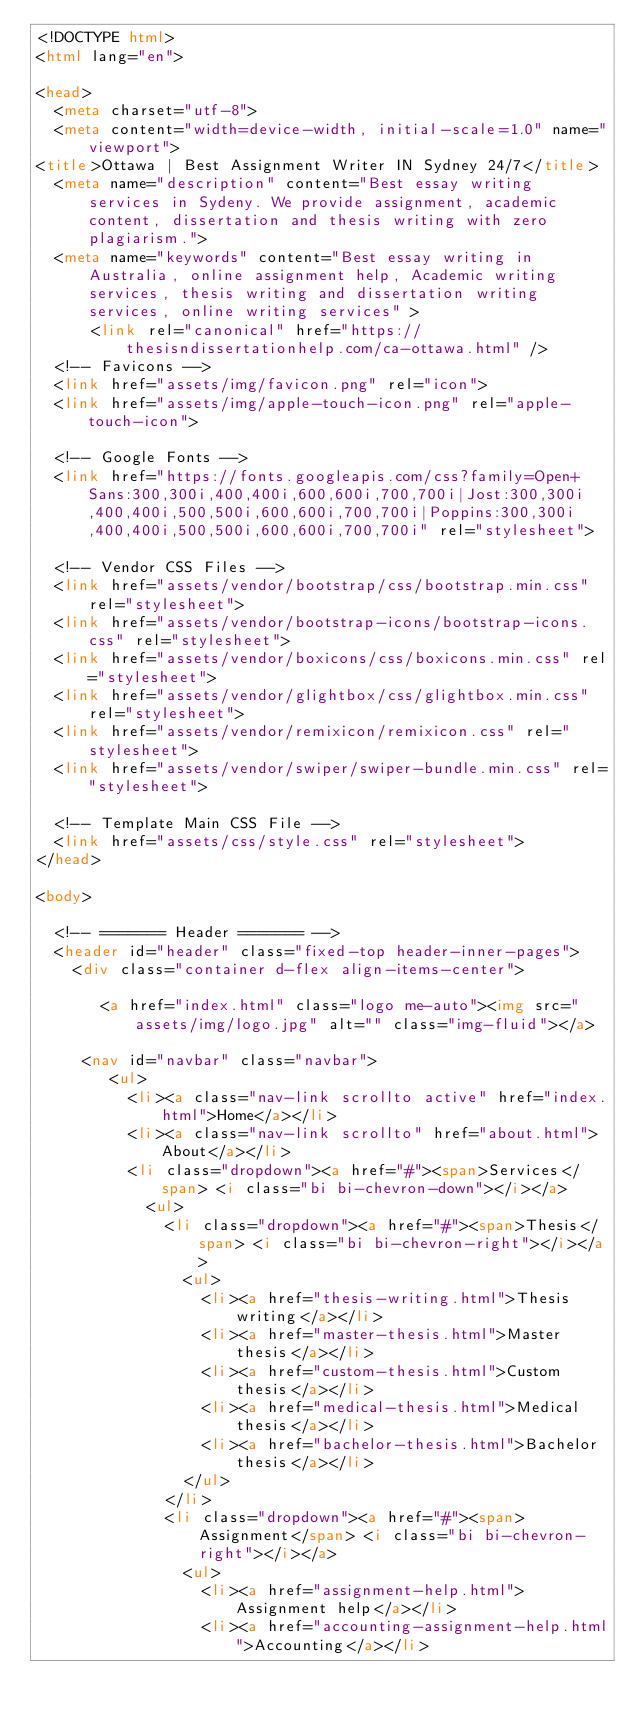<code> <loc_0><loc_0><loc_500><loc_500><_HTML_><!DOCTYPE html>
<html lang="en">
    
<head>
  <meta charset="utf-8">
  <meta content="width=device-width, initial-scale=1.0" name="viewport">
<title>Ottawa | Best Assignment Writer IN Sydney 24/7</title>
  <meta name="description" content="Best essay writing services in Sydeny. We provide assignment, academic content, dissertation and thesis writing with zero plagiarism.">
  <meta name="keywords" content="Best essay writing in Australia, online assignment help, Academic writing services, thesis writing and dissertation writing services, online writing services" >
      <link rel="canonical" href="https://thesisndissertationhelp.com/ca-ottawa.html" />
  <!-- Favicons -->
  <link href="assets/img/favicon.png" rel="icon">
  <link href="assets/img/apple-touch-icon.png" rel="apple-touch-icon">

  <!-- Google Fonts -->
  <link href="https://fonts.googleapis.com/css?family=Open+Sans:300,300i,400,400i,600,600i,700,700i|Jost:300,300i,400,400i,500,500i,600,600i,700,700i|Poppins:300,300i,400,400i,500,500i,600,600i,700,700i" rel="stylesheet">

  <!-- Vendor CSS Files -->
  <link href="assets/vendor/bootstrap/css/bootstrap.min.css" rel="stylesheet">
  <link href="assets/vendor/bootstrap-icons/bootstrap-icons.css" rel="stylesheet">
  <link href="assets/vendor/boxicons/css/boxicons.min.css" rel="stylesheet">
  <link href="assets/vendor/glightbox/css/glightbox.min.css" rel="stylesheet">
  <link href="assets/vendor/remixicon/remixicon.css" rel="stylesheet">
  <link href="assets/vendor/swiper/swiper-bundle.min.css" rel="stylesheet">

  <!-- Template Main CSS File -->
  <link href="assets/css/style.css" rel="stylesheet">
</head>

<body>

  <!-- ======= Header ======= -->
  <header id="header" class="fixed-top header-inner-pages">
    <div class="container d-flex align-items-center">

       <a href="index.html" class="logo me-auto"><img src="assets/img/logo.jpg" alt="" class="img-fluid"></a>
       
     <nav id="navbar" class="navbar">
        <ul>
          <li><a class="nav-link scrollto active" href="index.html">Home</a></li>
          <li><a class="nav-link scrollto" href="about.html">About</a></li>
          <li class="dropdown"><a href="#"><span>Services</span> <i class="bi bi-chevron-down"></i></a>
            <ul>
              <li class="dropdown"><a href="#"><span>Thesis</span> <i class="bi bi-chevron-right"></i></a>
                <ul>
                  <li><a href="thesis-writing.html">Thesis writing</a></li>
                  <li><a href="master-thesis.html">Master thesis</a></li>
                  <li><a href="custom-thesis.html">Custom thesis</a></li>
                  <li><a href="medical-thesis.html">Medical thesis</a></li>
                  <li><a href="bachelor-thesis.html">Bachelor thesis</a></li>
                </ul>
              </li>
              <li class="dropdown"><a href="#"><span>Assignment</span> <i class="bi bi-chevron-right"></i></a>
                <ul>
                  <li><a href="assignment-help.html">Assignment help</a></li>
                  <li><a href="accounting-assignment-help.html">Accounting</a></li></code> 